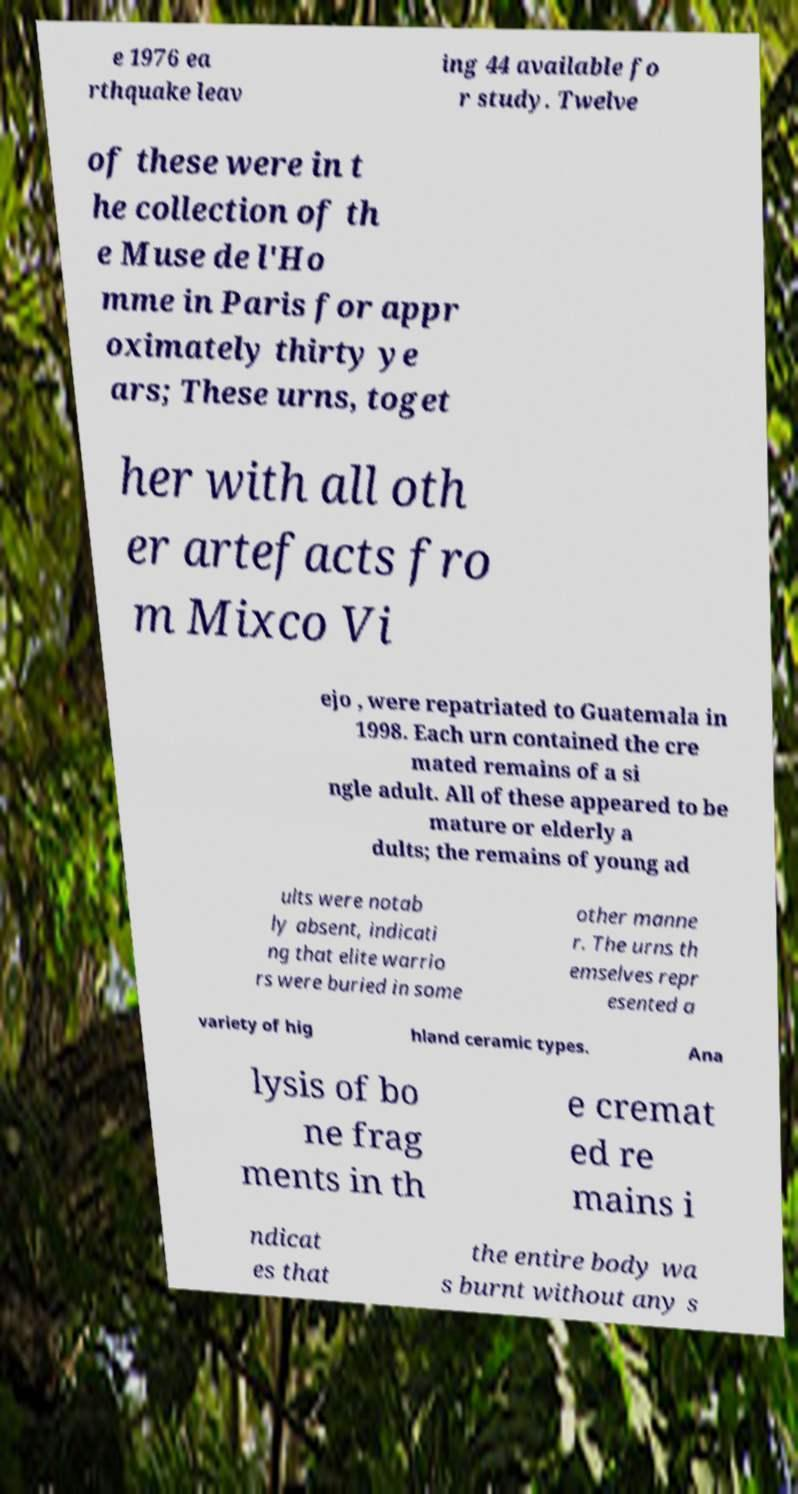Can you accurately transcribe the text from the provided image for me? e 1976 ea rthquake leav ing 44 available fo r study. Twelve of these were in t he collection of th e Muse de l'Ho mme in Paris for appr oximately thirty ye ars; These urns, toget her with all oth er artefacts fro m Mixco Vi ejo , were repatriated to Guatemala in 1998. Each urn contained the cre mated remains of a si ngle adult. All of these appeared to be mature or elderly a dults; the remains of young ad ults were notab ly absent, indicati ng that elite warrio rs were buried in some other manne r. The urns th emselves repr esented a variety of hig hland ceramic types. Ana lysis of bo ne frag ments in th e cremat ed re mains i ndicat es that the entire body wa s burnt without any s 